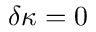Convert formula to latex. <formula><loc_0><loc_0><loc_500><loc_500>\delta \kappa = 0</formula> 